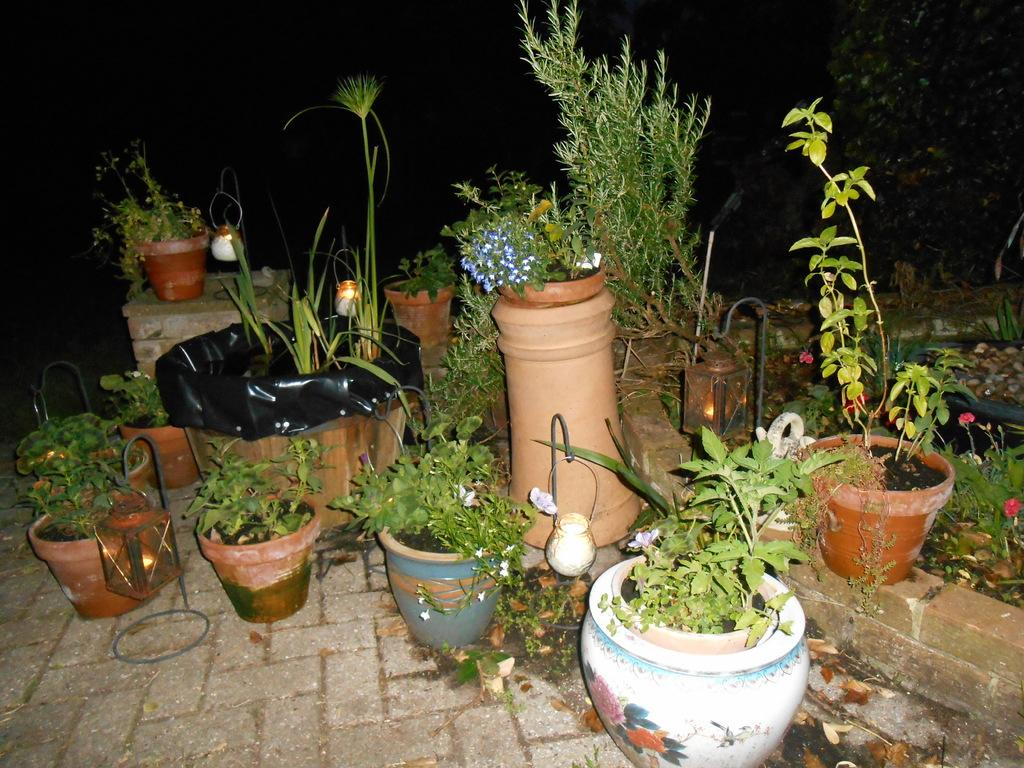What types of objects can be seen in the image related to plants and lighting? There are different types of flower pots and candles in the image. What else is present in the image related to the candles? There are different kinds of candle holders in the image. Where are the flower pots and candle holders placed in the image? The flower pots and candle holders are placed on the wall and floor. What type of plastic material is used to make the flowers in the image? There are no flowers made of plastic in the image; the flower pots contain real plants. 